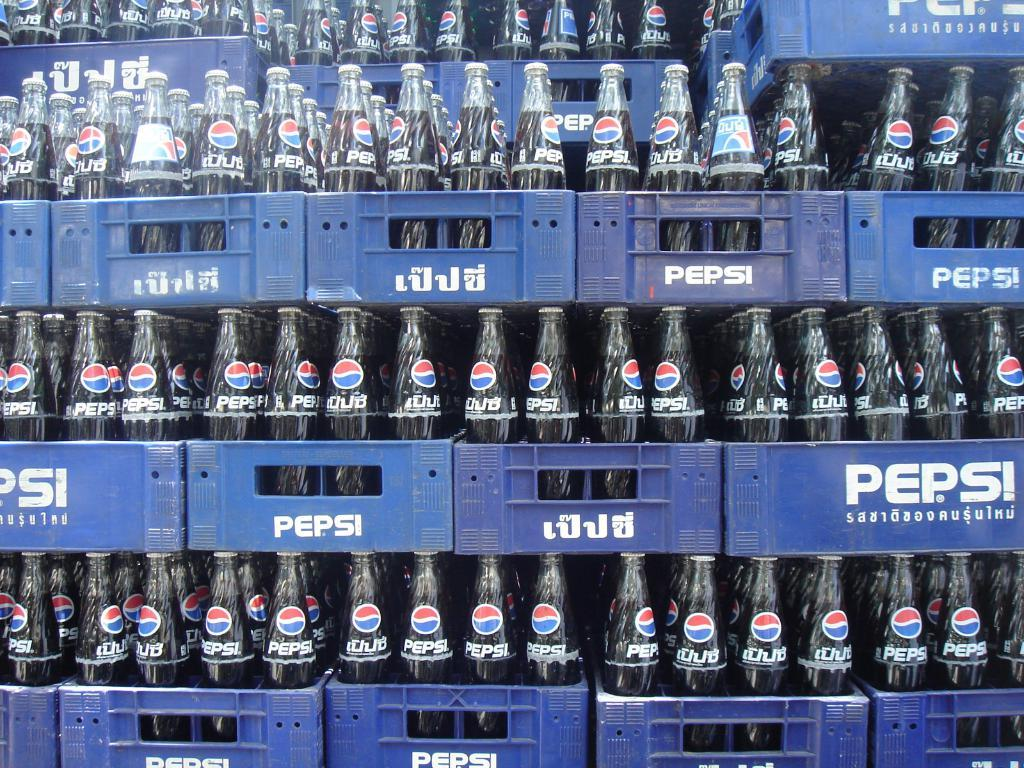<image>
Render a clear and concise summary of the photo. many blue crates of pepsi bottles stacked up 